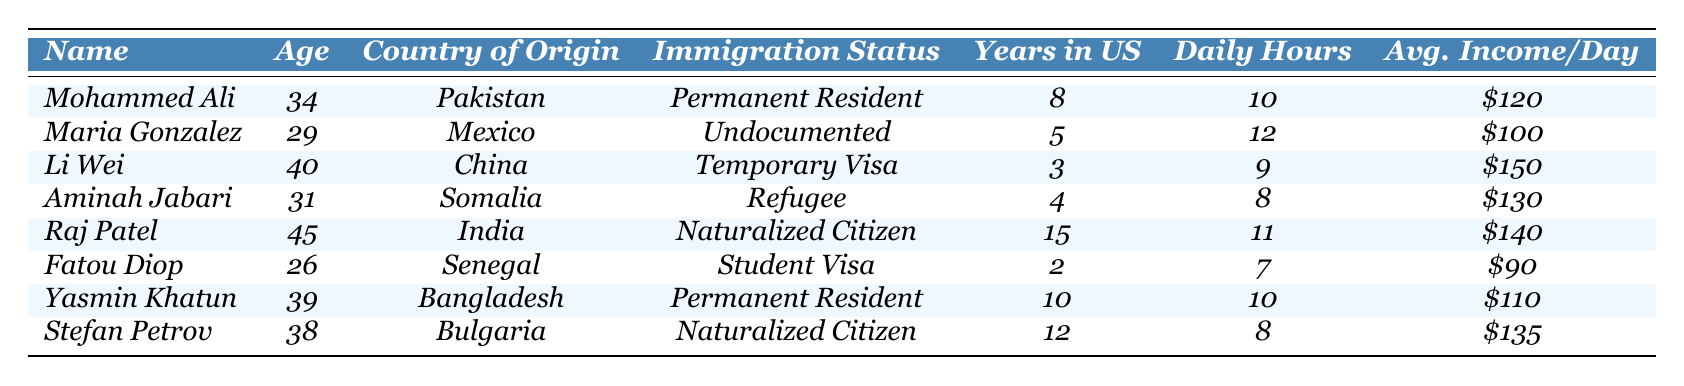What is the average daily income of the taxi drivers listed? To find the average daily income, first, sum the individual daily incomes: $120 + $100 + $150 + $130 + $140 + $90 + $110 + $135 = $1,075. Then divide by the number of drivers (8), which gives $1,075 / 8 = $134.375. Thus, the average daily income is approximately $134.38.
Answer: $134.38 How many taxi drivers have been in the U.S. for more than 10 years? By examining the years in the U.S. for each driver, we see that only Raj Patel has been in the U.S. for 15 years. This makes him the only taxi driver who has spent more than 10 years in the country.
Answer: 1 Which immigration status has the highest average income per day? To determine this, calculate the average daily income for each immigration status by first grouping the drivers and then averaging their incomes: 1. Permanent Resident: ($120 + $110) / 2 = $115; 2. Undocumented: $100; 3. Temporary Visa: $150; 4. Refugee: $130; 5. Naturalized Citizen: ($140 + $135) / 2 = $137.5; 6. Student Visa: $90. The immigration status with the highest average is Temporary Visa at $150.
Answer: Temporary Visa Is there a taxi driver from China? Searching through the country of origin column, we find that Li Wei is from China, confirming the presence of a taxi driver from that country.
Answer: Yes What is the difference in daily hours worked between the driver with the highest and lowest income? The driver with the highest income is Li Wei who works 9 hours and earns $150 per day, while the driver with the lowest income is Fatou Diop who works 7 hours and earns $90. The difference in daily hours worked is 9 - 7 = 2 hours.
Answer: 2 hours Which driver has the longest tenure in the U.S. and what is their average income per day? Raj Patel has been in the U.S. for 15 years, the longest among the listed drivers. His average income per day is $140.
Answer: Raj Patel, $140 How many drivers work more than 10 hours a day? By examining the daily hours worked, we see that three drivers (Maria Gonzalez, Raj Patel, and Mohammed Ali) work more than 10 hours a day.
Answer: 3 What percentage of the drivers are permanent residents? There are 2 permanent residents in the list (Mohammed Ali and Yasmin Khatun) out of 8 drivers total. The percentage is (2 / 8) * 100 = 25%.
Answer: 25% Who are the drivers from Africa and what are their immigration statuses? The drivers from Africa are Aminah Jabari from Somalia, who is a refugee, and Fatou Diop from Senegal, who is on a student visa.
Answer: Aminah Jabari (Refugee), Fatou Diop (Student Visa) What is the age range of the taxi drivers in the table? The youngest driver is Fatou Diop at 26 years old, and the oldest is Raj Patel at 45 years old. The age range is thus 45 - 26 = 19 years.
Answer: 19 years 